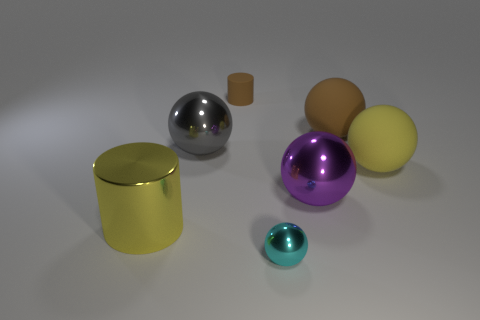Is the color of the big matte thing left of the big yellow matte object the same as the tiny shiny thing?
Make the answer very short. No. Is the metal cylinder the same size as the cyan metallic ball?
Ensure brevity in your answer.  No. There is a metallic object that is the same size as the brown cylinder; what shape is it?
Provide a short and direct response. Sphere. Is the size of the gray shiny object behind the cyan shiny object the same as the small matte cylinder?
Offer a terse response. No. What is the material of the cylinder that is the same size as the cyan thing?
Offer a terse response. Rubber. Is there a brown rubber thing that is to the right of the cylinder behind the cylinder that is in front of the yellow sphere?
Your response must be concise. Yes. Are there any other things that are the same shape as the small cyan metal thing?
Offer a very short reply. Yes. There is a small object right of the small cylinder; does it have the same color as the small object that is behind the large shiny cylinder?
Your answer should be compact. No. Is there a shiny cylinder?
Offer a very short reply. Yes. There is a big object that is the same color as the small matte cylinder; what is its material?
Keep it short and to the point. Rubber. 